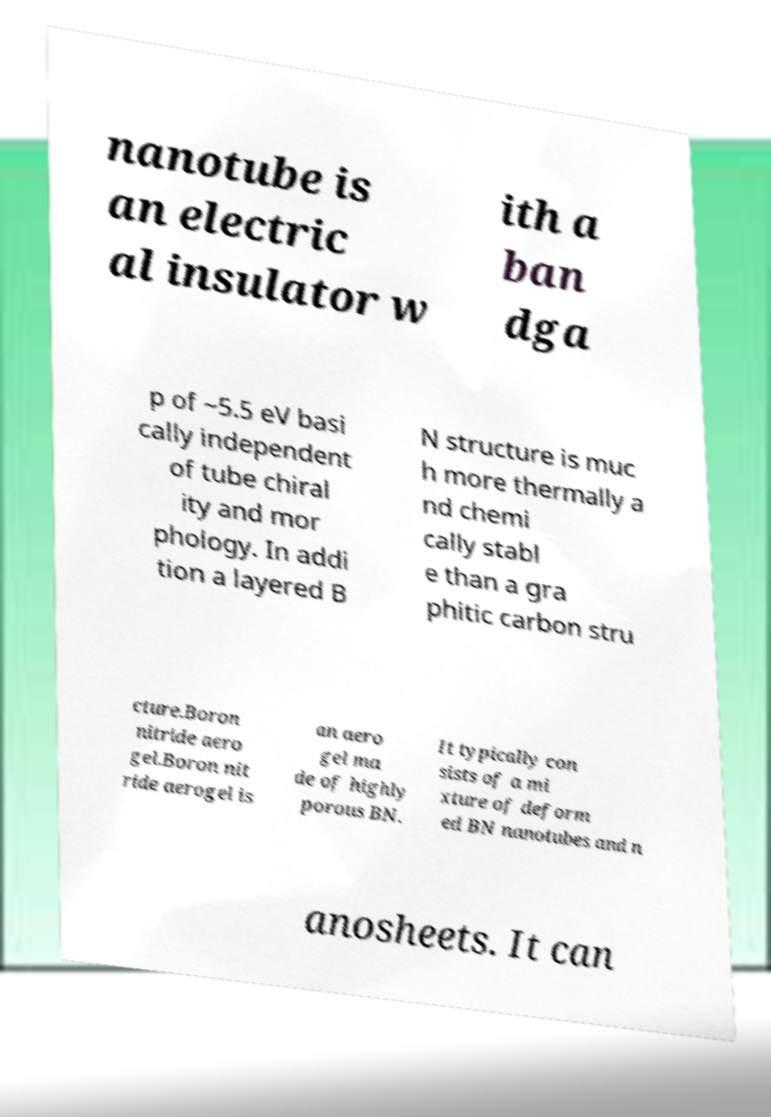What messages or text are displayed in this image? I need them in a readable, typed format. nanotube is an electric al insulator w ith a ban dga p of ~5.5 eV basi cally independent of tube chiral ity and mor phology. In addi tion a layered B N structure is muc h more thermally a nd chemi cally stabl e than a gra phitic carbon stru cture.Boron nitride aero gel.Boron nit ride aerogel is an aero gel ma de of highly porous BN. It typically con sists of a mi xture of deform ed BN nanotubes and n anosheets. It can 